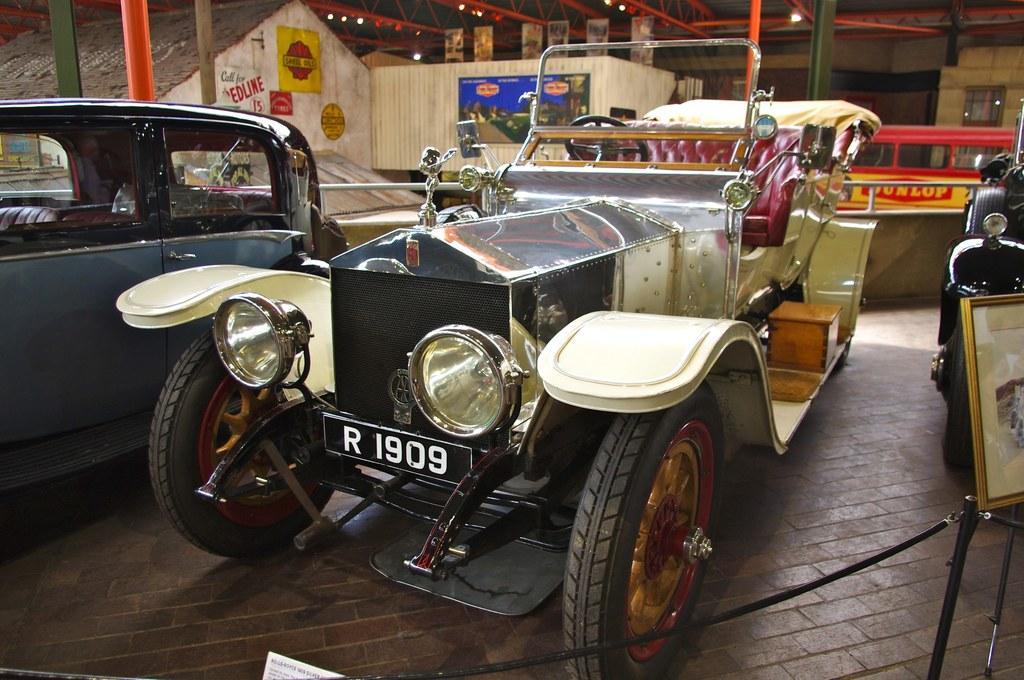In one or two sentences, can you explain what this image depicts? In this image there are three vehicles are in the middle of this image. There are some houses in the background. There are some lights arranged on the top of this image,and there is a floor in the bottom of this image. 